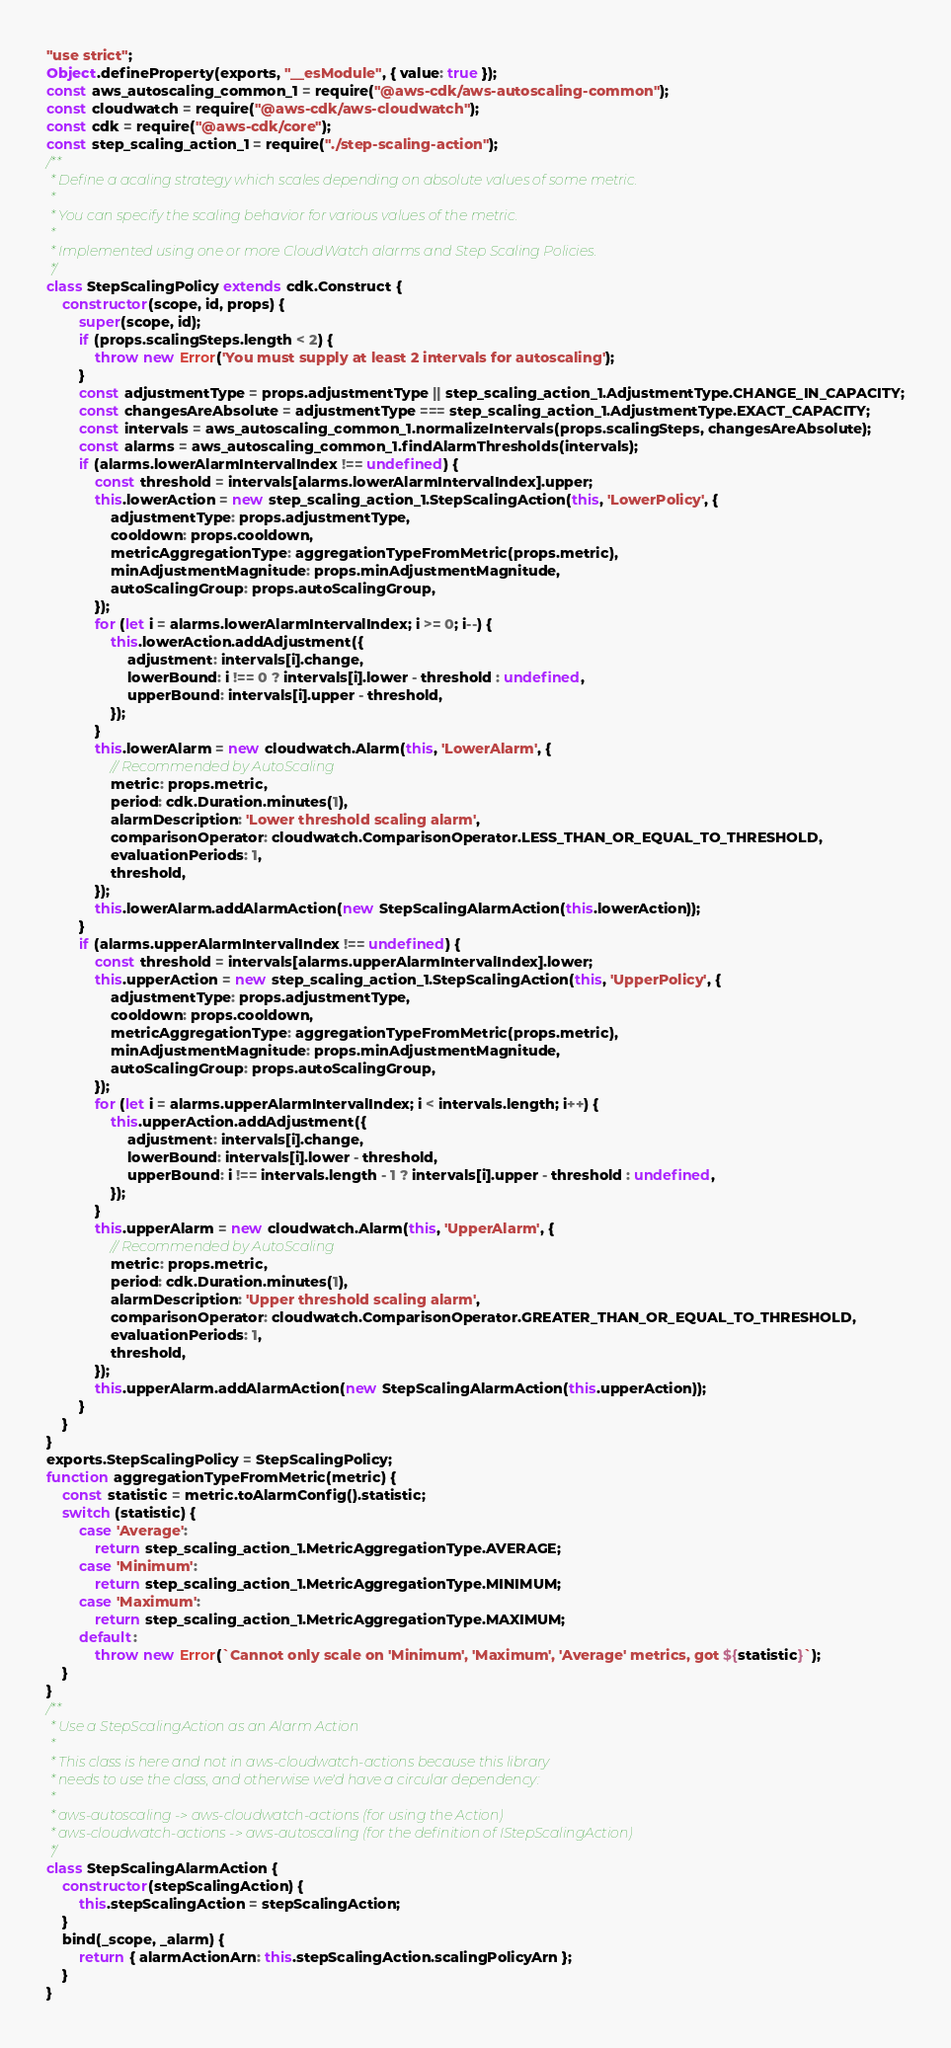Convert code to text. <code><loc_0><loc_0><loc_500><loc_500><_JavaScript_>"use strict";
Object.defineProperty(exports, "__esModule", { value: true });
const aws_autoscaling_common_1 = require("@aws-cdk/aws-autoscaling-common");
const cloudwatch = require("@aws-cdk/aws-cloudwatch");
const cdk = require("@aws-cdk/core");
const step_scaling_action_1 = require("./step-scaling-action");
/**
 * Define a acaling strategy which scales depending on absolute values of some metric.
 *
 * You can specify the scaling behavior for various values of the metric.
 *
 * Implemented using one or more CloudWatch alarms and Step Scaling Policies.
 */
class StepScalingPolicy extends cdk.Construct {
    constructor(scope, id, props) {
        super(scope, id);
        if (props.scalingSteps.length < 2) {
            throw new Error('You must supply at least 2 intervals for autoscaling');
        }
        const adjustmentType = props.adjustmentType || step_scaling_action_1.AdjustmentType.CHANGE_IN_CAPACITY;
        const changesAreAbsolute = adjustmentType === step_scaling_action_1.AdjustmentType.EXACT_CAPACITY;
        const intervals = aws_autoscaling_common_1.normalizeIntervals(props.scalingSteps, changesAreAbsolute);
        const alarms = aws_autoscaling_common_1.findAlarmThresholds(intervals);
        if (alarms.lowerAlarmIntervalIndex !== undefined) {
            const threshold = intervals[alarms.lowerAlarmIntervalIndex].upper;
            this.lowerAction = new step_scaling_action_1.StepScalingAction(this, 'LowerPolicy', {
                adjustmentType: props.adjustmentType,
                cooldown: props.cooldown,
                metricAggregationType: aggregationTypeFromMetric(props.metric),
                minAdjustmentMagnitude: props.minAdjustmentMagnitude,
                autoScalingGroup: props.autoScalingGroup,
            });
            for (let i = alarms.lowerAlarmIntervalIndex; i >= 0; i--) {
                this.lowerAction.addAdjustment({
                    adjustment: intervals[i].change,
                    lowerBound: i !== 0 ? intervals[i].lower - threshold : undefined,
                    upperBound: intervals[i].upper - threshold,
                });
            }
            this.lowerAlarm = new cloudwatch.Alarm(this, 'LowerAlarm', {
                // Recommended by AutoScaling
                metric: props.metric,
                period: cdk.Duration.minutes(1),
                alarmDescription: 'Lower threshold scaling alarm',
                comparisonOperator: cloudwatch.ComparisonOperator.LESS_THAN_OR_EQUAL_TO_THRESHOLD,
                evaluationPeriods: 1,
                threshold,
            });
            this.lowerAlarm.addAlarmAction(new StepScalingAlarmAction(this.lowerAction));
        }
        if (alarms.upperAlarmIntervalIndex !== undefined) {
            const threshold = intervals[alarms.upperAlarmIntervalIndex].lower;
            this.upperAction = new step_scaling_action_1.StepScalingAction(this, 'UpperPolicy', {
                adjustmentType: props.adjustmentType,
                cooldown: props.cooldown,
                metricAggregationType: aggregationTypeFromMetric(props.metric),
                minAdjustmentMagnitude: props.minAdjustmentMagnitude,
                autoScalingGroup: props.autoScalingGroup,
            });
            for (let i = alarms.upperAlarmIntervalIndex; i < intervals.length; i++) {
                this.upperAction.addAdjustment({
                    adjustment: intervals[i].change,
                    lowerBound: intervals[i].lower - threshold,
                    upperBound: i !== intervals.length - 1 ? intervals[i].upper - threshold : undefined,
                });
            }
            this.upperAlarm = new cloudwatch.Alarm(this, 'UpperAlarm', {
                // Recommended by AutoScaling
                metric: props.metric,
                period: cdk.Duration.minutes(1),
                alarmDescription: 'Upper threshold scaling alarm',
                comparisonOperator: cloudwatch.ComparisonOperator.GREATER_THAN_OR_EQUAL_TO_THRESHOLD,
                evaluationPeriods: 1,
                threshold,
            });
            this.upperAlarm.addAlarmAction(new StepScalingAlarmAction(this.upperAction));
        }
    }
}
exports.StepScalingPolicy = StepScalingPolicy;
function aggregationTypeFromMetric(metric) {
    const statistic = metric.toAlarmConfig().statistic;
    switch (statistic) {
        case 'Average':
            return step_scaling_action_1.MetricAggregationType.AVERAGE;
        case 'Minimum':
            return step_scaling_action_1.MetricAggregationType.MINIMUM;
        case 'Maximum':
            return step_scaling_action_1.MetricAggregationType.MAXIMUM;
        default:
            throw new Error(`Cannot only scale on 'Minimum', 'Maximum', 'Average' metrics, got ${statistic}`);
    }
}
/**
 * Use a StepScalingAction as an Alarm Action
 *
 * This class is here and not in aws-cloudwatch-actions because this library
 * needs to use the class, and otherwise we'd have a circular dependency:
 *
 * aws-autoscaling -> aws-cloudwatch-actions (for using the Action)
 * aws-cloudwatch-actions -> aws-autoscaling (for the definition of IStepScalingAction)
 */
class StepScalingAlarmAction {
    constructor(stepScalingAction) {
        this.stepScalingAction = stepScalingAction;
    }
    bind(_scope, _alarm) {
        return { alarmActionArn: this.stepScalingAction.scalingPolicyArn };
    }
}</code> 